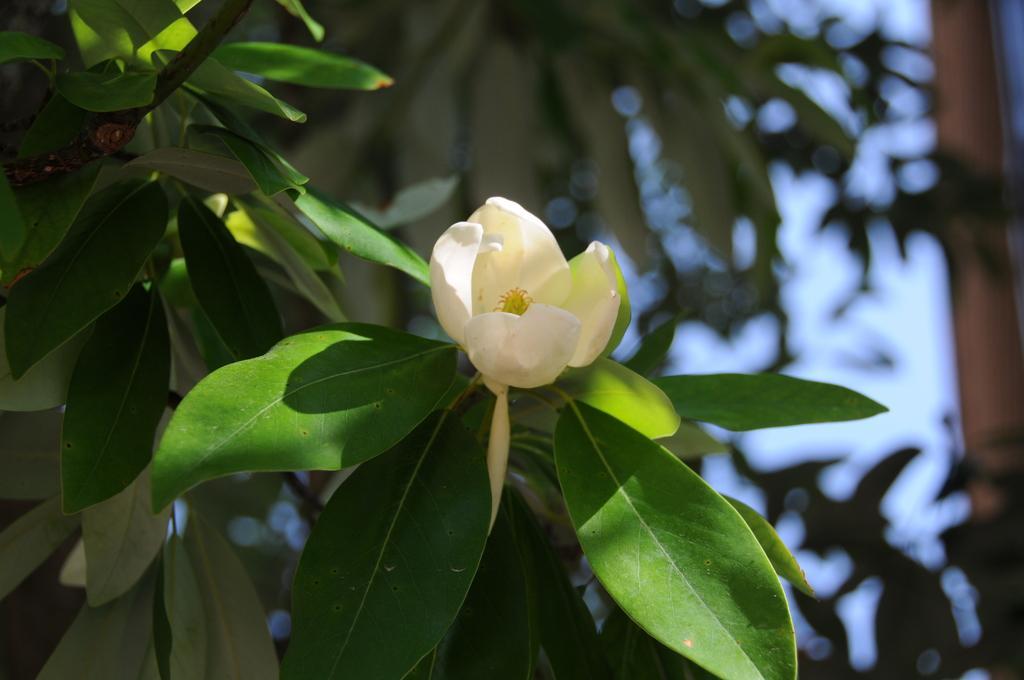Could you give a brief overview of what you see in this image? In the center of the image we can see a flower which is in white color. In the background there are trees and sky. 